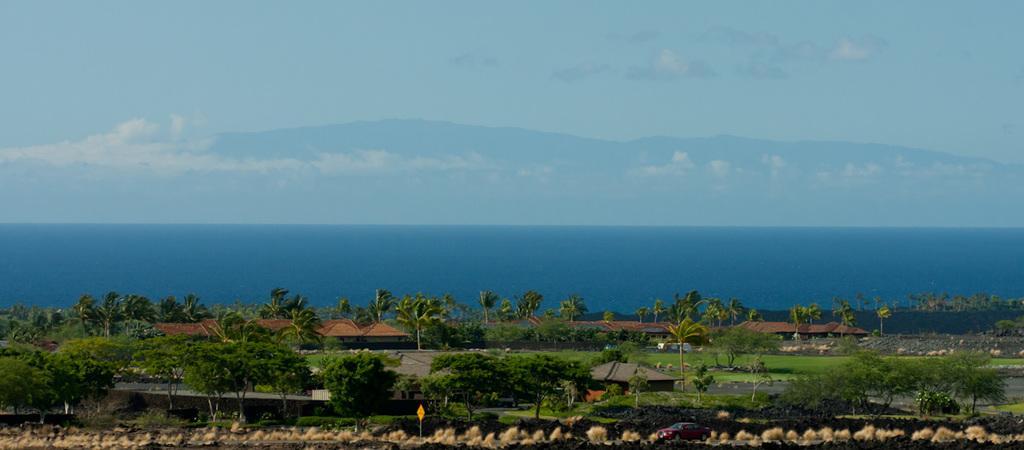Can you describe this image briefly? In this picture we can observe trees and houses. We can observe an ocean. In the background there are hills and a sky with some clouds. 